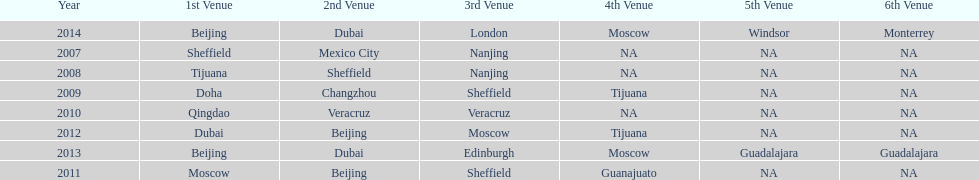Name a year whose second venue was the same as 2011. 2012. 